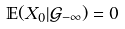Convert formula to latex. <formula><loc_0><loc_0><loc_500><loc_500>\mathbb { E } ( X _ { 0 } | \mathcal { G } _ { - \infty } ) = 0</formula> 